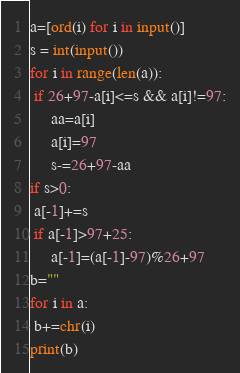Convert code to text. <code><loc_0><loc_0><loc_500><loc_500><_Python_>a=[ord(i) for i in input()]
s = int(input())
for i in range(len(a)):
 if 26+97-a[i]<=s && a[i]!=97:
     aa=a[i]
     a[i]=97
     s-=26+97-aa
if s>0:
 a[-1]+=s
 if a[-1]>97+25:
     a[-1]=(a[-1]-97)%26+97
b=""
for i in a:
 b+=chr(i) 
print(b)</code> 